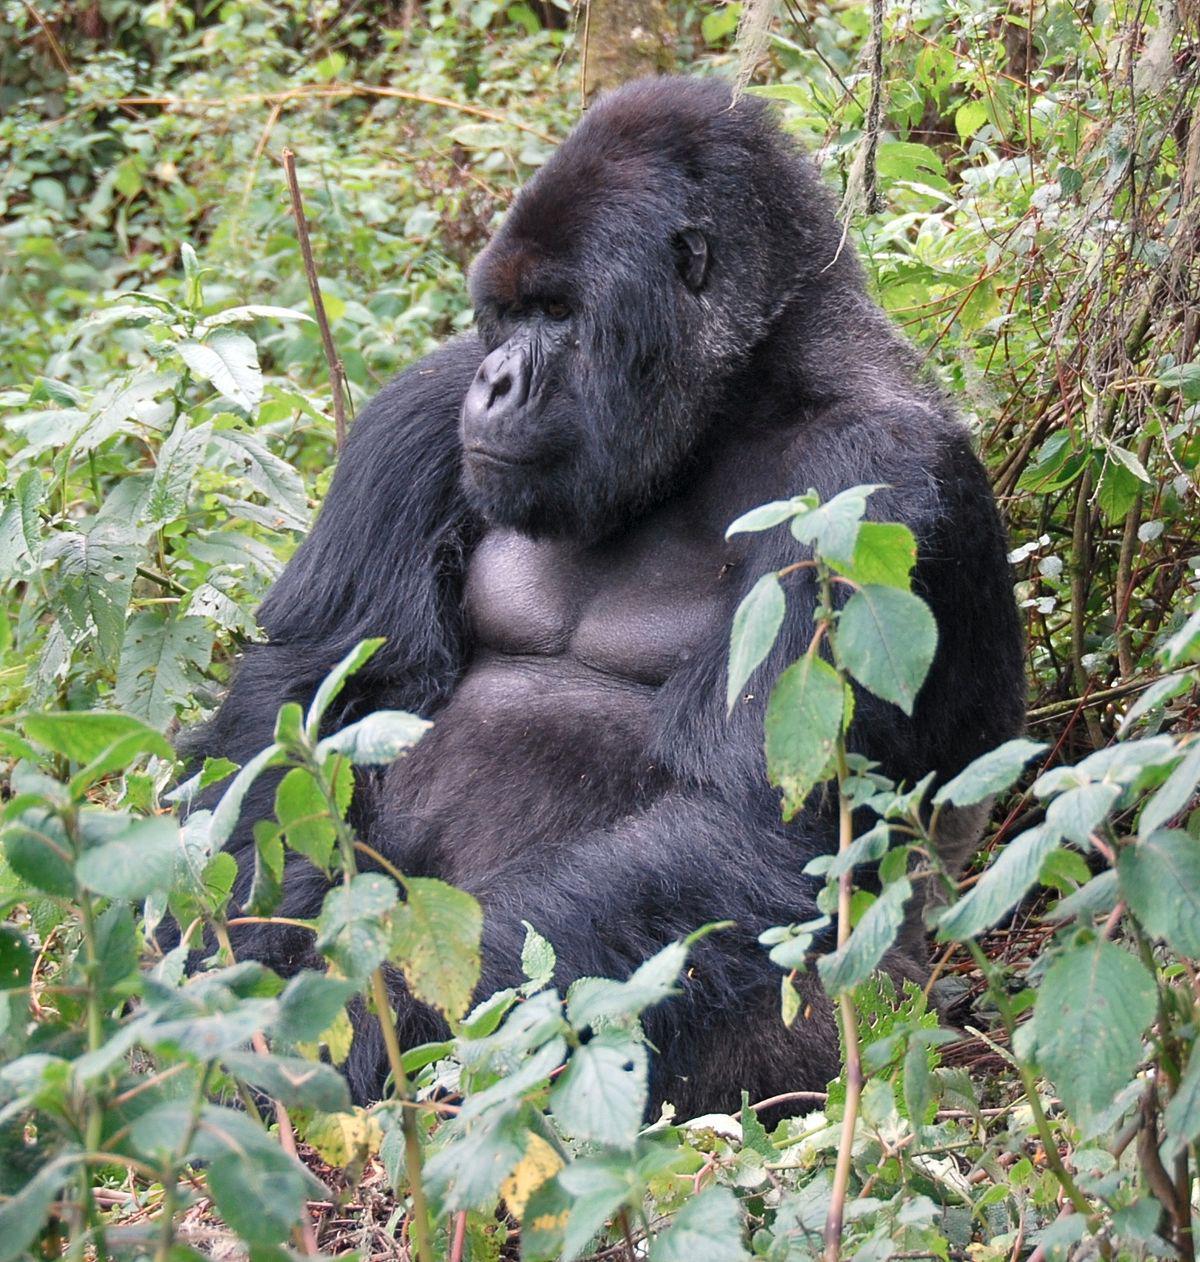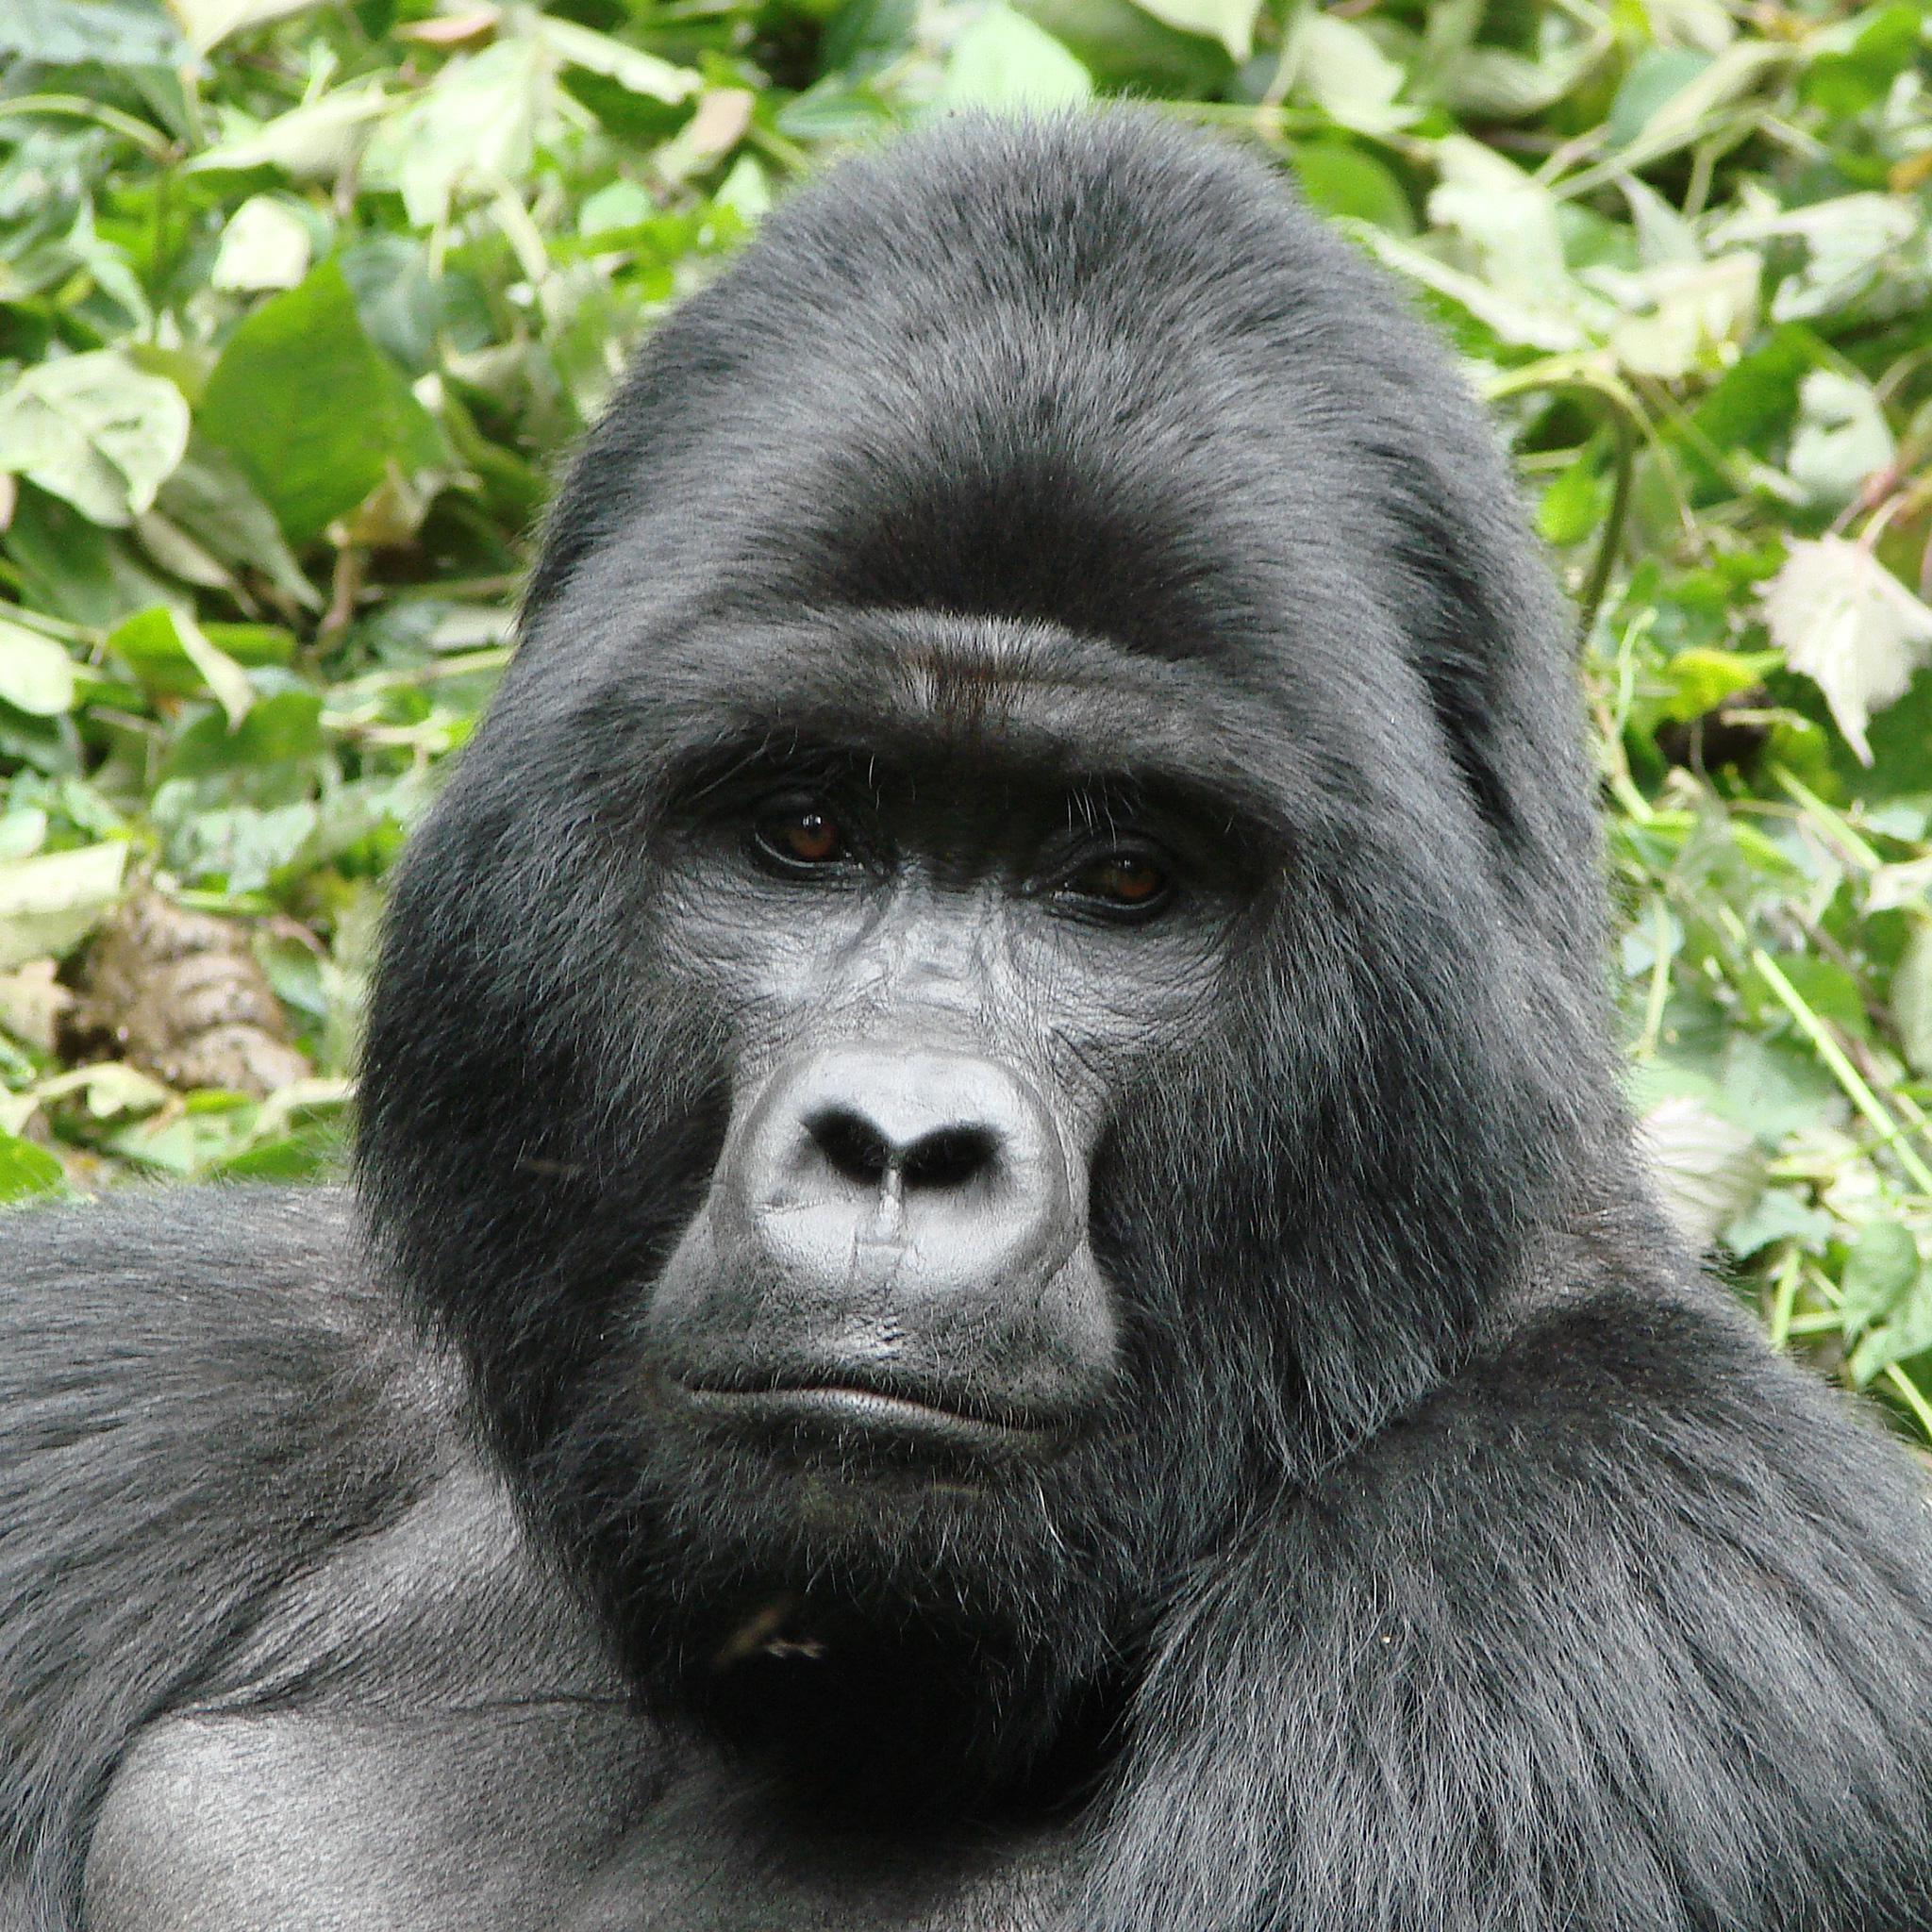The first image is the image on the left, the second image is the image on the right. Assess this claim about the two images: "At least one baby gorilla is cuddled up with it's mother.". Correct or not? Answer yes or no. No. The first image is the image on the left, the second image is the image on the right. Examine the images to the left and right. Is the description "Right image shows a young gorilla held on the chest of an adult gorilla, surrounded by foliage." accurate? Answer yes or no. No. 